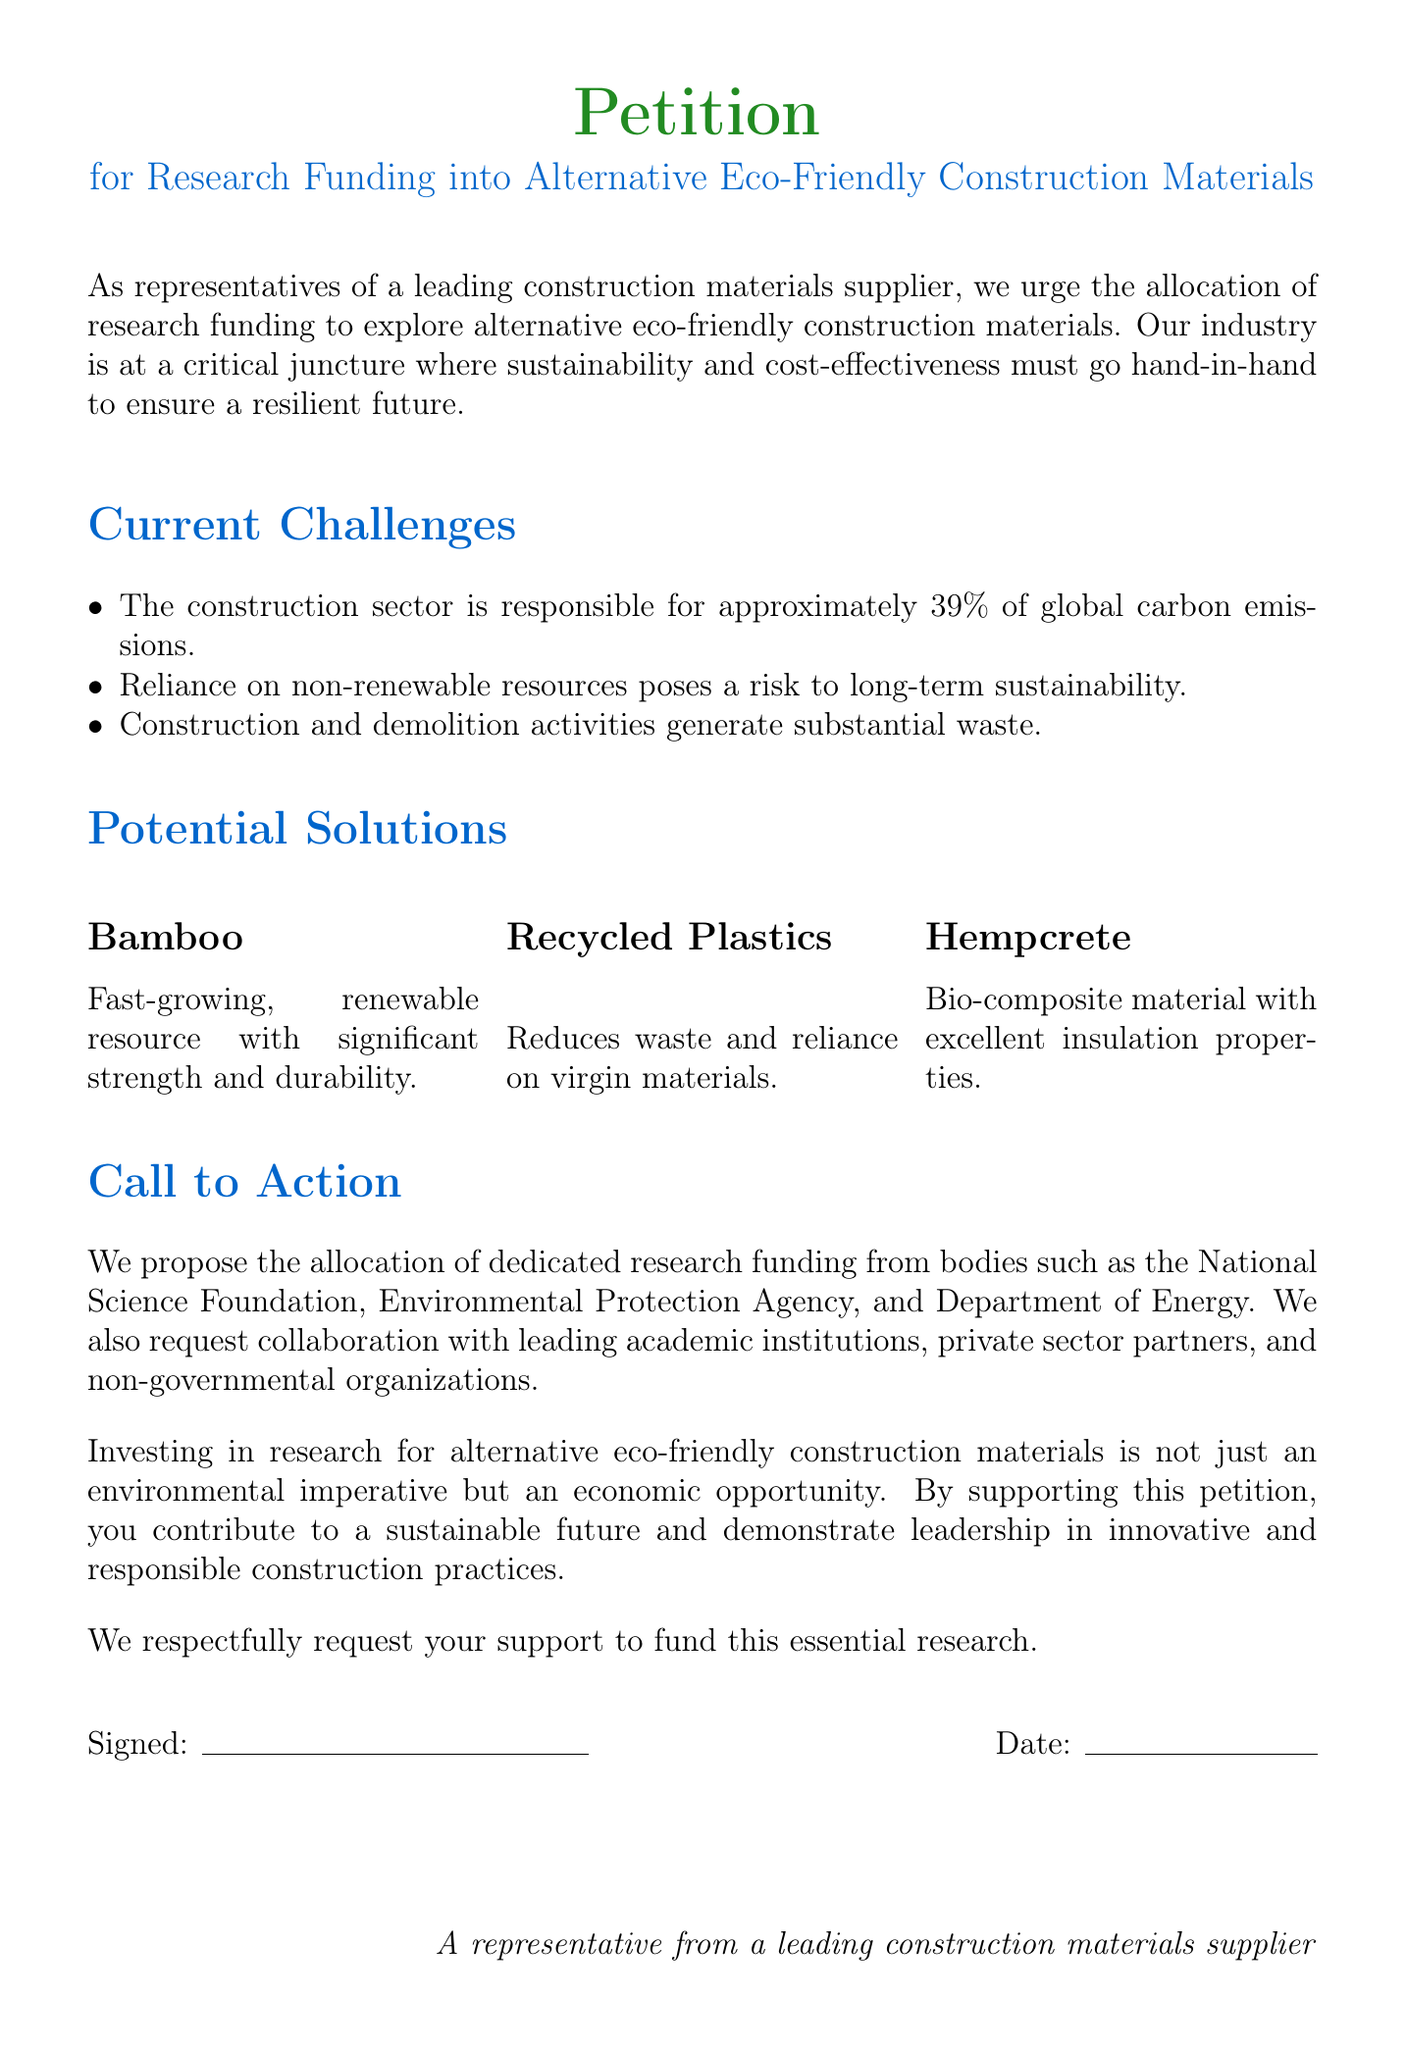What is the purpose of the petition? The petition urges the allocation of research funding to explore alternative eco-friendly construction materials.
Answer: Research funding for eco-friendly materials How much of global carbon emissions is the construction sector responsible for? The document states that the construction sector is responsible for approximately 39% of global carbon emissions.
Answer: 39% What are the three suggested alternative materials mentioned? The document lists bamboo, recycled plastics, and hempcrete as suggested materials.
Answer: Bamboo, recycled plastics, hempcrete Which organizations are proposed to allocate research funding? The petition proposes allocations from the National Science Foundation, Environmental Protection Agency, and Department of Energy.
Answer: National Science Foundation, Environmental Protection Agency, Department of Energy What is one characteristic of bamboo as a construction material? The document describes bamboo as a fast-growing, renewable resource with significant strength and durability.
Answer: Fast-growing, renewable resource What is hempcrete known for? The document highlights that hempcrete is a bio-composite material with excellent insulation properties.
Answer: Excellent insulation properties What action is requested in the petition? The petition requests support for funding essential research into eco-friendly construction materials.
Answer: Support to fund research What is one reason mentioned for investing in research for alternative materials? The document states that investing in research is both an environmental imperative and an economic opportunity.
Answer: Environmental imperative and economic opportunity Who signed the petition? The document indicates that it is signed by a representative from a leading construction materials supplier.
Answer: A representative from a leading construction materials supplier 